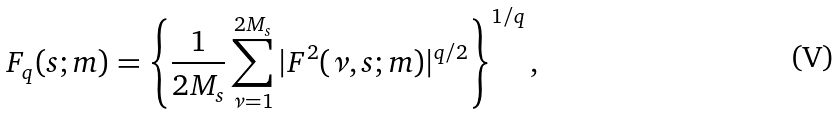<formula> <loc_0><loc_0><loc_500><loc_500>F _ { q } ( s ; m ) = \left \{ \frac { 1 } { 2 M _ { s } } \sum _ { \nu = 1 } ^ { 2 M _ { s } } | F ^ { 2 } ( \nu , s ; m ) | ^ { q / 2 } \right \} ^ { 1 / q } ,</formula> 